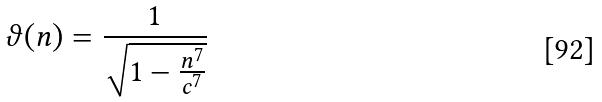<formula> <loc_0><loc_0><loc_500><loc_500>\vartheta ( n ) = \frac { 1 } { \sqrt { 1 - \frac { n ^ { 7 } } { c ^ { 7 } } } }</formula> 